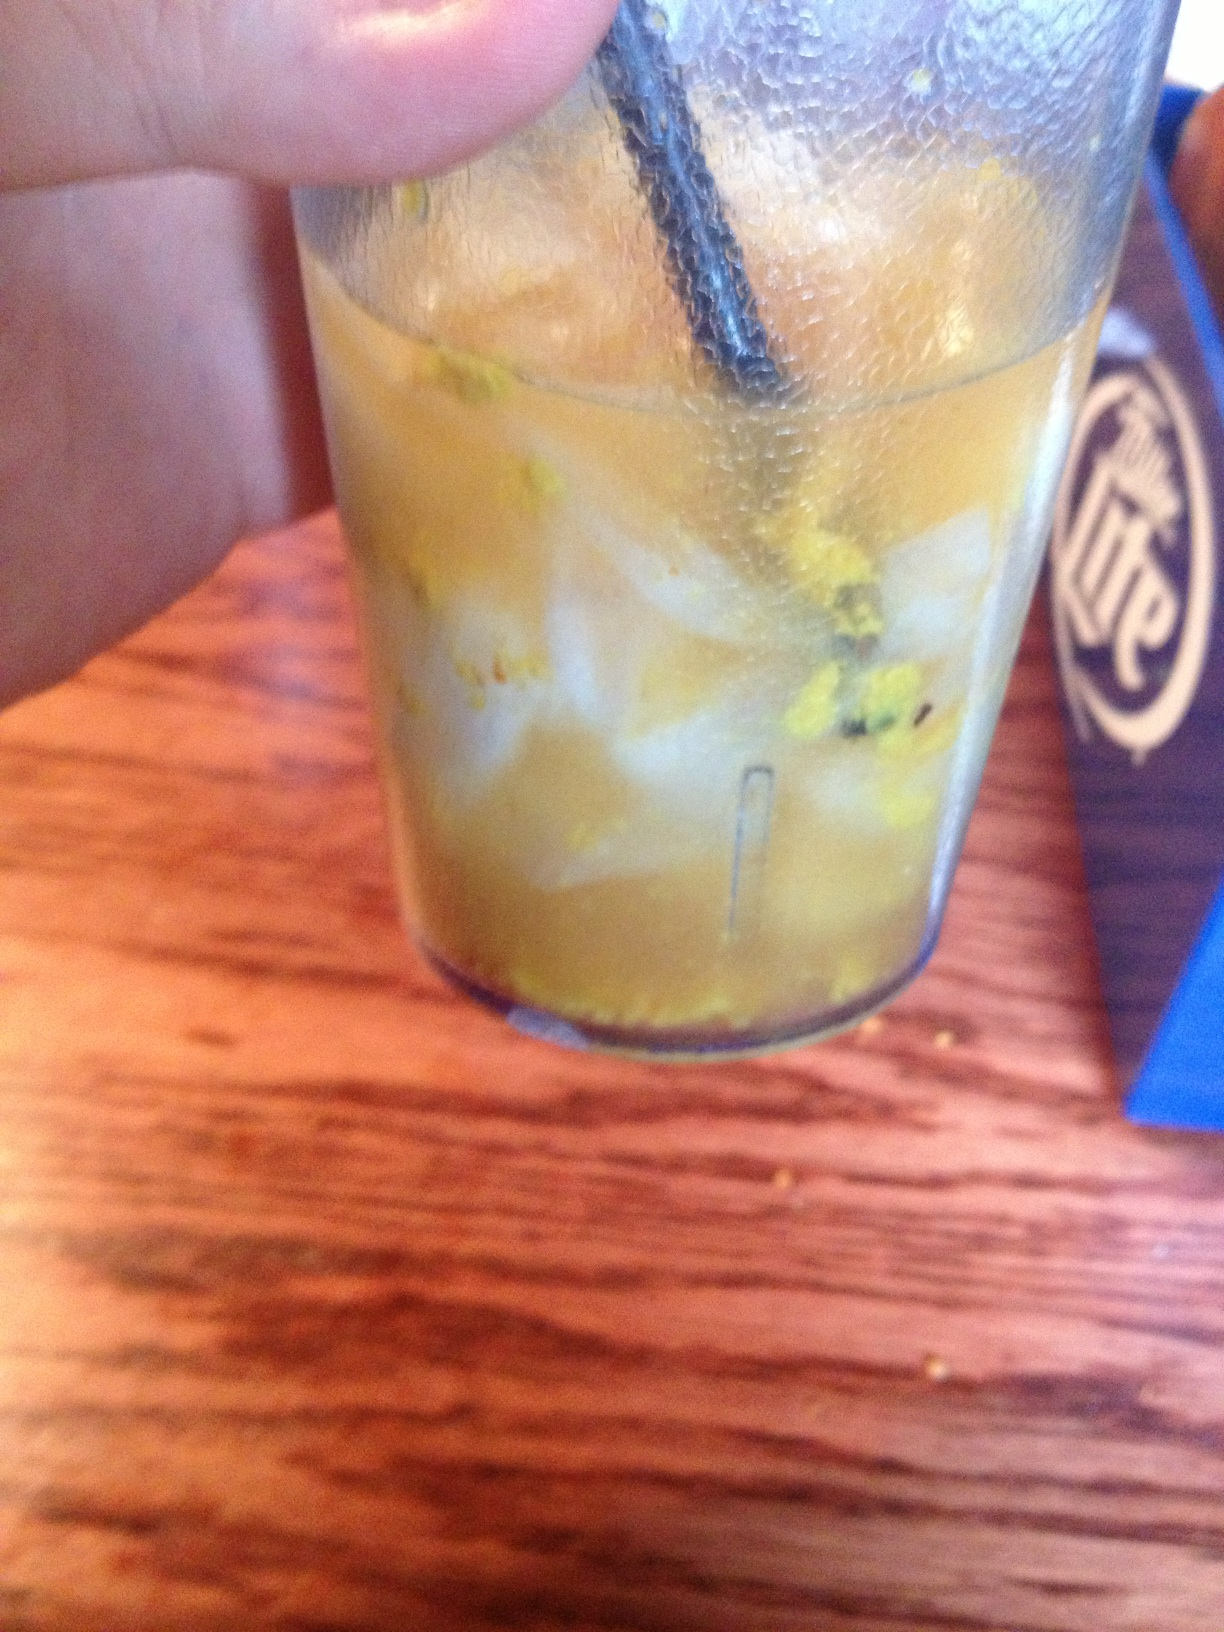This drink has an unappetizing look. Should I be worried? While the appearance of a drink can sometimes be deceiving, if it looks unappetizing and tastes strange, it's best to trust your instincts. It's always a good idea to ask the staff about its ingredients and preparation to ensure it's safe to consume. If it still seems off, don't hesitate to request a replacement. 